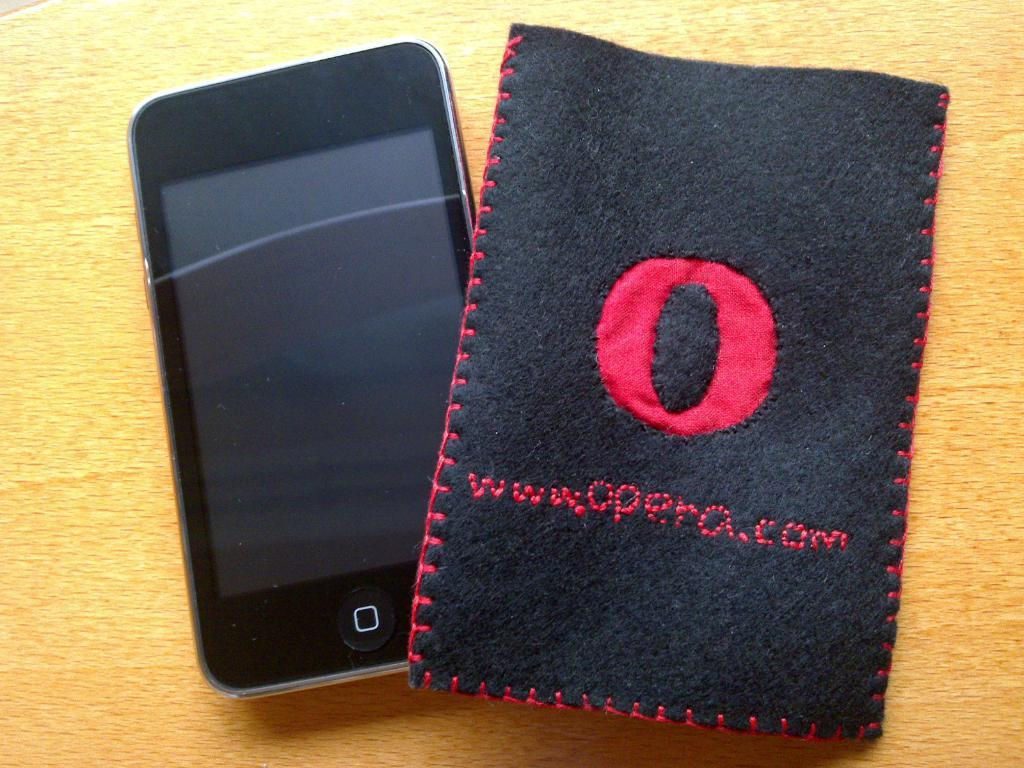<image>
Create a compact narrative representing the image presented. A black smartphone is shown with a cloth "opera.com" casing. 